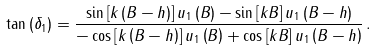Convert formula to latex. <formula><loc_0><loc_0><loc_500><loc_500>\tan \left ( { \delta _ { 1 } } \right ) = { \frac { \sin \left [ { k \left ( { B - h } \right ) } \right ] u _ { 1 } \left ( B \right ) - \sin \left [ { k B } \right ] u _ { 1 } \left ( { B - h } \right ) } { - \cos \left [ { k \left ( { B - h } \right ) } \right ] u _ { 1 } \left ( B \right ) + \cos \left [ { k B } \right ] u _ { 1 } \left ( { B - h } \right ) } } \, .</formula> 